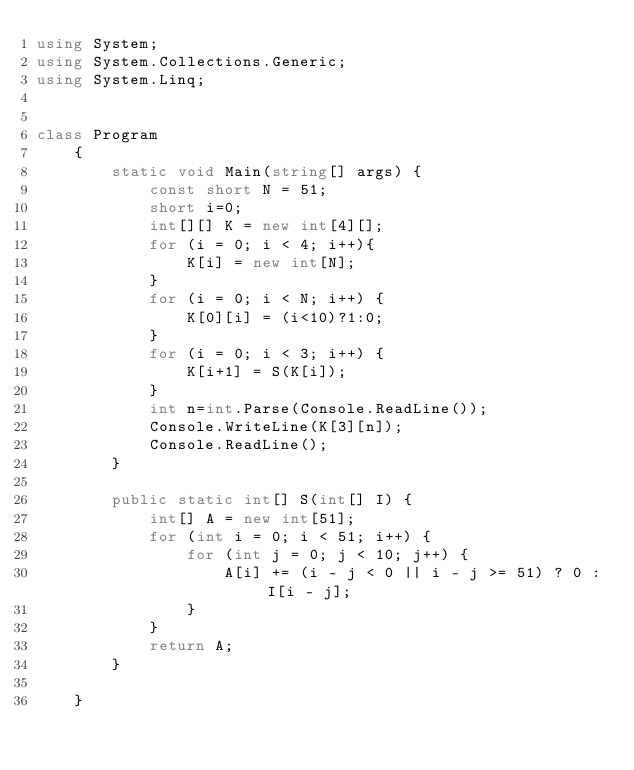<code> <loc_0><loc_0><loc_500><loc_500><_C#_>using System;
using System.Collections.Generic;
using System.Linq;


class Program
    {
        static void Main(string[] args) {
            const short N = 51;
            short i=0;
            int[][] K = new int[4][];
            for (i = 0; i < 4; i++){
                K[i] = new int[N];
            }
            for (i = 0; i < N; i++) {
                K[0][i] = (i<10)?1:0;
            }
            for (i = 0; i < 3; i++) {
                K[i+1] = S(K[i]);
            }
            int n=int.Parse(Console.ReadLine());
            Console.WriteLine(K[3][n]);
            Console.ReadLine();
        }

        public static int[] S(int[] I) {
            int[] A = new int[51];
            for (int i = 0; i < 51; i++) {
                for (int j = 0; j < 10; j++) {
                    A[i] += (i - j < 0 || i - j >= 51) ? 0 : I[i - j];
                }
            }
            return A;
        }

    }</code> 